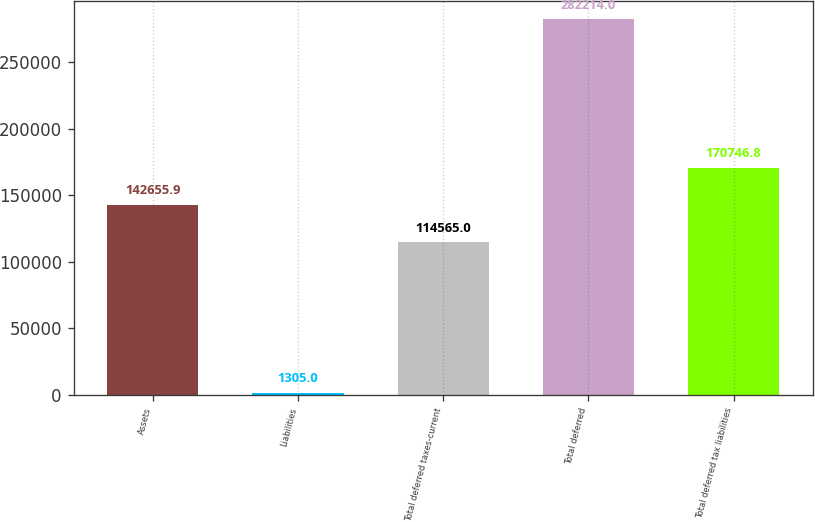Convert chart to OTSL. <chart><loc_0><loc_0><loc_500><loc_500><bar_chart><fcel>Assets<fcel>Liabilities<fcel>Total deferred taxes-current<fcel>Total deferred<fcel>Total deferred tax liabilities<nl><fcel>142656<fcel>1305<fcel>114565<fcel>282214<fcel>170747<nl></chart> 